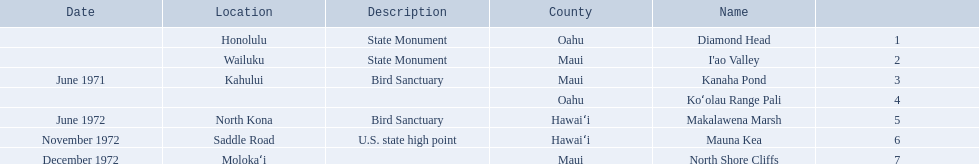What are all of the landmark names? Diamond Head, I'ao Valley, Kanaha Pond, Koʻolau Range Pali, Makalawena Marsh, Mauna Kea, North Shore Cliffs. Where are they located? Honolulu, Wailuku, Kahului, , North Kona, Saddle Road, Molokaʻi. And which landmark has no listed location? Koʻolau Range Pali. 